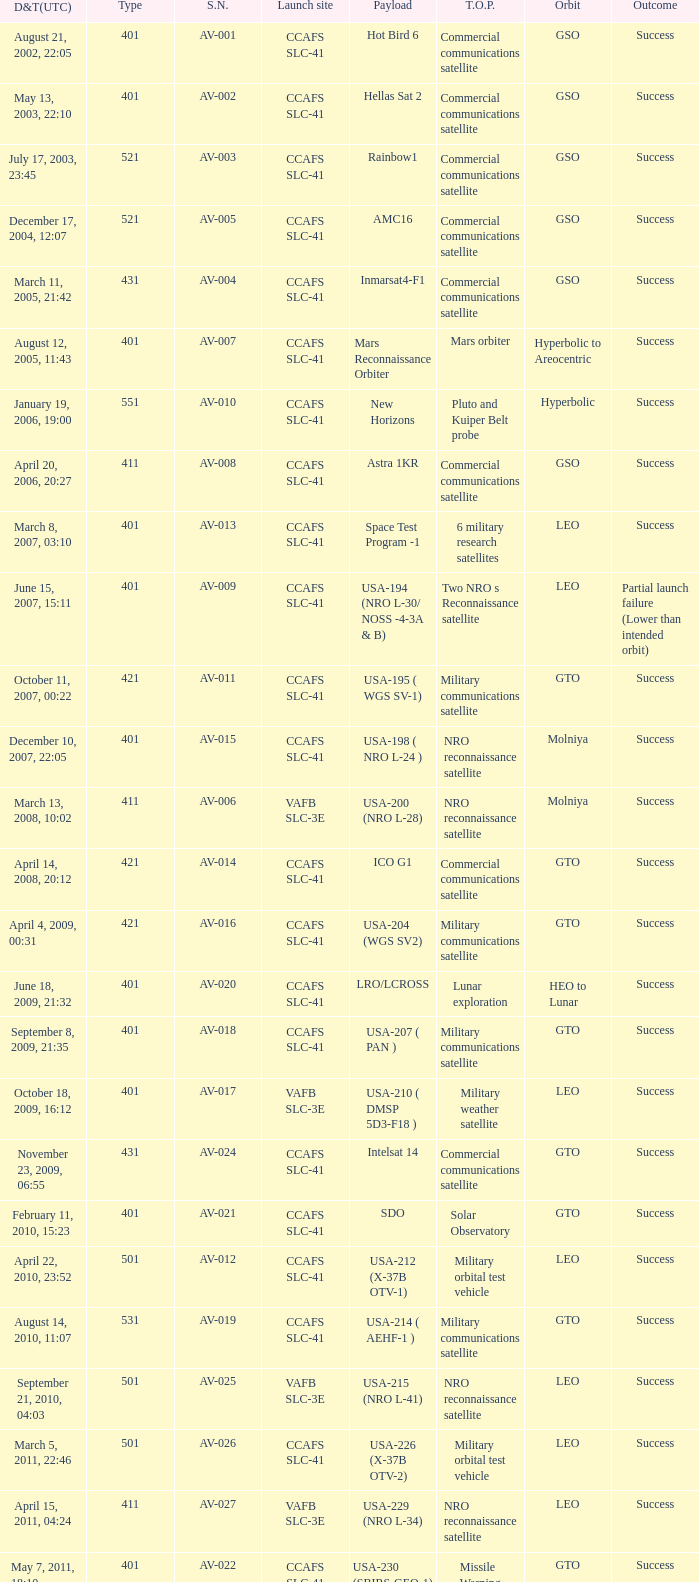For the payload of Van Allen Belts Exploration what's the serial number? AV-032. 